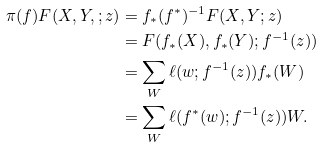<formula> <loc_0><loc_0><loc_500><loc_500>\pi ( f ) F ( X , Y , ; z ) & = f _ { * } ( f ^ { * } ) ^ { - 1 } F ( X , Y ; z ) \\ & = F ( f _ { * } ( X ) , f _ { * } ( Y ) ; f ^ { - 1 } ( z ) ) \\ & = \sum _ { W } \ell ( w ; f ^ { - 1 } ( z ) ) f _ { * } ( W ) \\ & = \sum _ { W } \ell ( f ^ { * } ( w ) ; f ^ { - 1 } ( z ) ) W .</formula> 